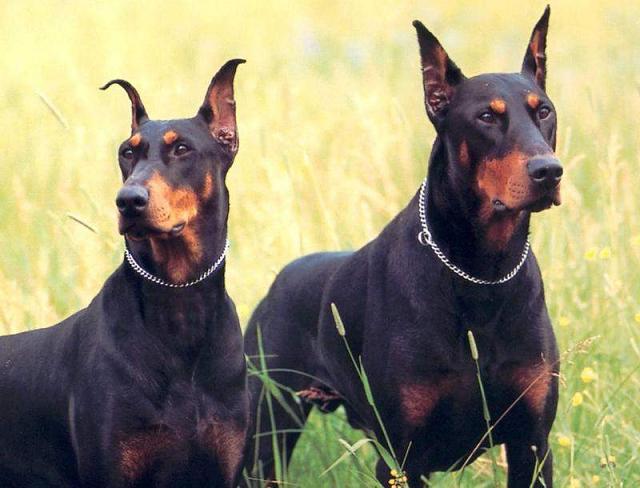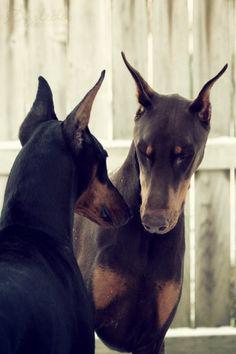The first image is the image on the left, the second image is the image on the right. Considering the images on both sides, is "The right image contains exactly two dogs." valid? Answer yes or no. Yes. The first image is the image on the left, the second image is the image on the right. For the images displayed, is the sentence "The left image shows two forward-turned dobermans with pointy ears and collars posed side-by-side, and the right image shows two dobermans interacting with their noses close together." factually correct? Answer yes or no. Yes. 